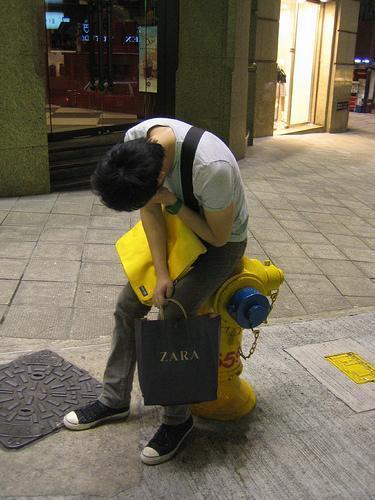How many handbags can be seen?
Give a very brief answer. 2. 